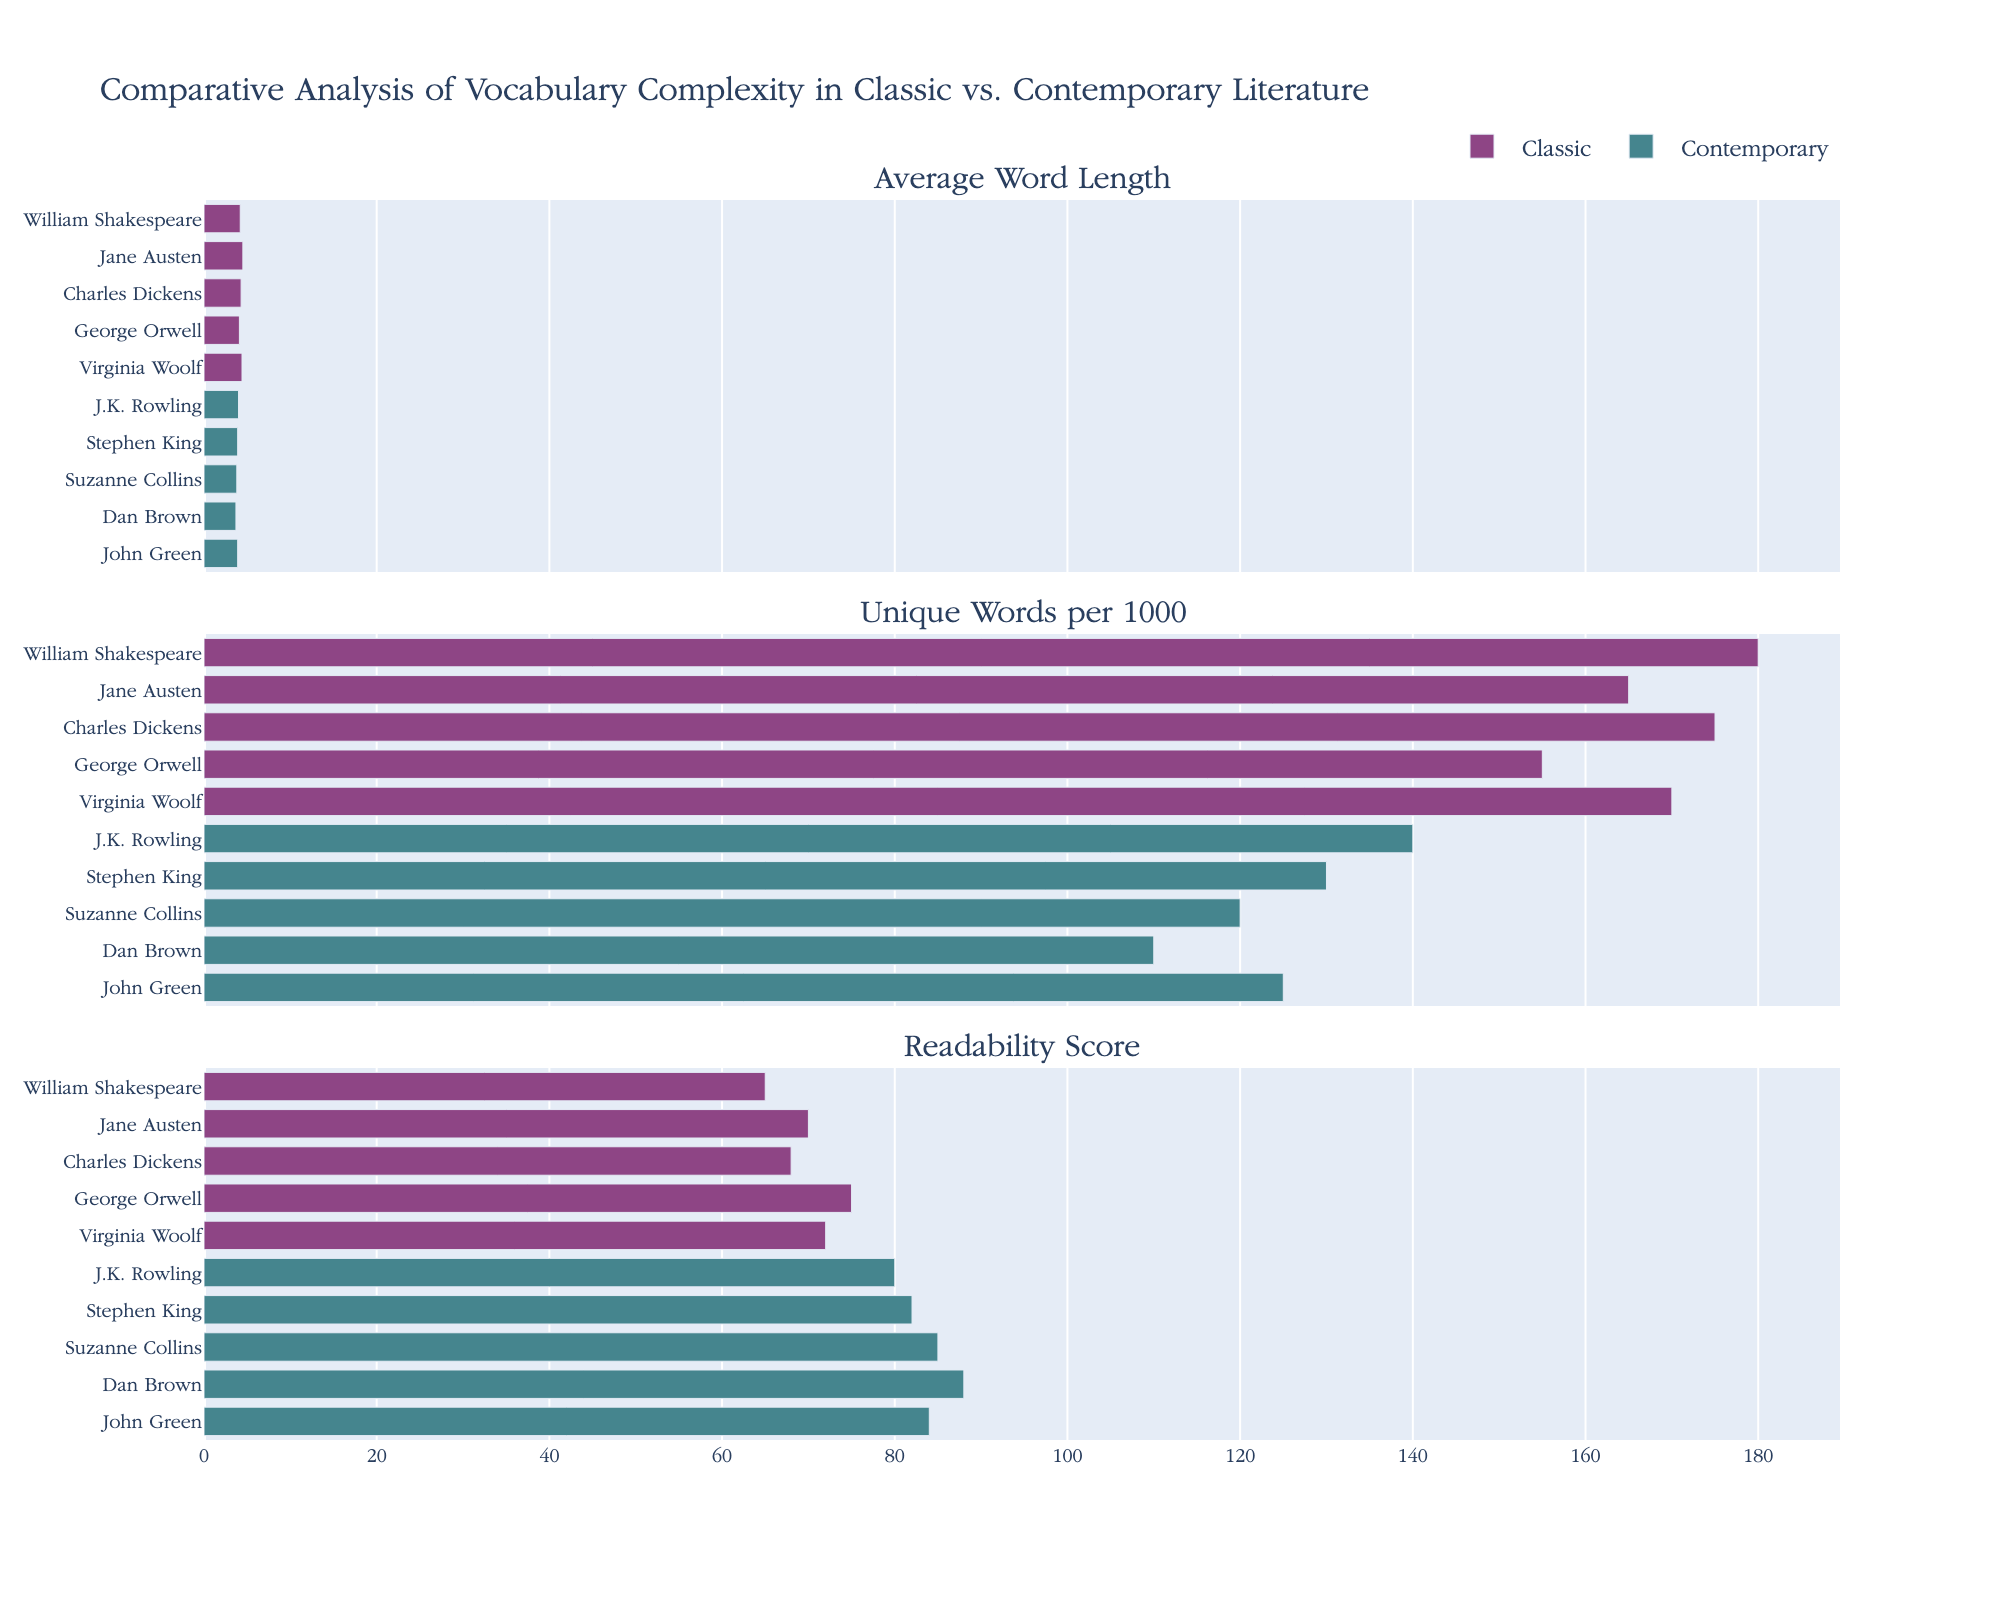What is the title of the figure? The title of the figure is located at the top center and visually highlights the main topic of the plots.
Answer: Adoption Rates of CSS Preprocessors (2015-2022) What are the labels of the subplots? The labels of the subplots are indicated as subplot titles which are found above each respective subplot. They represent the respective CSS preprocessors.
Answer: Sass, Less, Stylus, PostCSS How many data points are there for each preprocessor? Each preprocessor has data points corresponding to each year from 2015 to 2022. By counting the points for any preprocessor, one can deduce the number of data points.
Answer: 8 Which preprocessor has the highest adoption rate in 2020? The subplot for 2020 shows a peak point at 80.9% within the 'Sass' preprocessor plot, which is the highest for that year.
Answer: Sass In which year does PostCSS surpass Less in terms of adoption rate? Observing the PostCSS and Less trends in their respective subplots, we see PostCSS surpasses Less in 2016.
Answer: 2016 By how much does the adoption rate of Stylus reduce from 2015 to 2022? We subtract the adoption rate of Stylus in 2022 (2.9%) from its rate in 2015 (12.1%).
Answer: 9.2% Describe the trend observed in the adoption rate of Sass from 2015 to 2022. The plot for Sass shows a steady upward trend with increasing adoption rates each year from 2015 (54.3%) to 2022 (83.7%).
Answer: Increasing trend Which preprocessor has the least adoption rate in 2022? We look at the endpoint for the year 2022 in each subplot; Stylus has the lowest percentage.
Answer: Stylus Does Less show any periods of growth in the displayed range? By observing the Less subplot, the adoption rate declines each year from 2015 to 2022, showing no growth.
Answer: No Between which consecutive years did PostCSS have the highest increase in adoption rate? The steepest slope in the PostCSS subplot occurs between 2021 (38.2%) and 2022 (42.6%) where the increase is calculated as 4.4%.
Answer: 2021-2022 